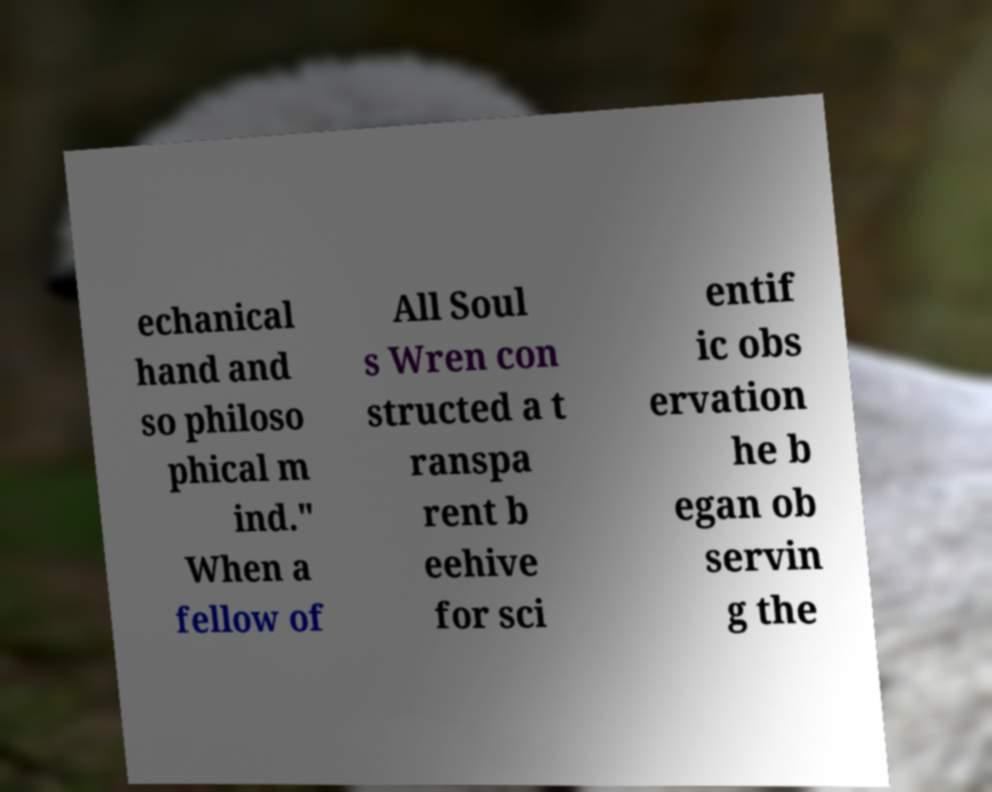Can you accurately transcribe the text from the provided image for me? echanical hand and so philoso phical m ind." When a fellow of All Soul s Wren con structed a t ranspa rent b eehive for sci entif ic obs ervation he b egan ob servin g the 